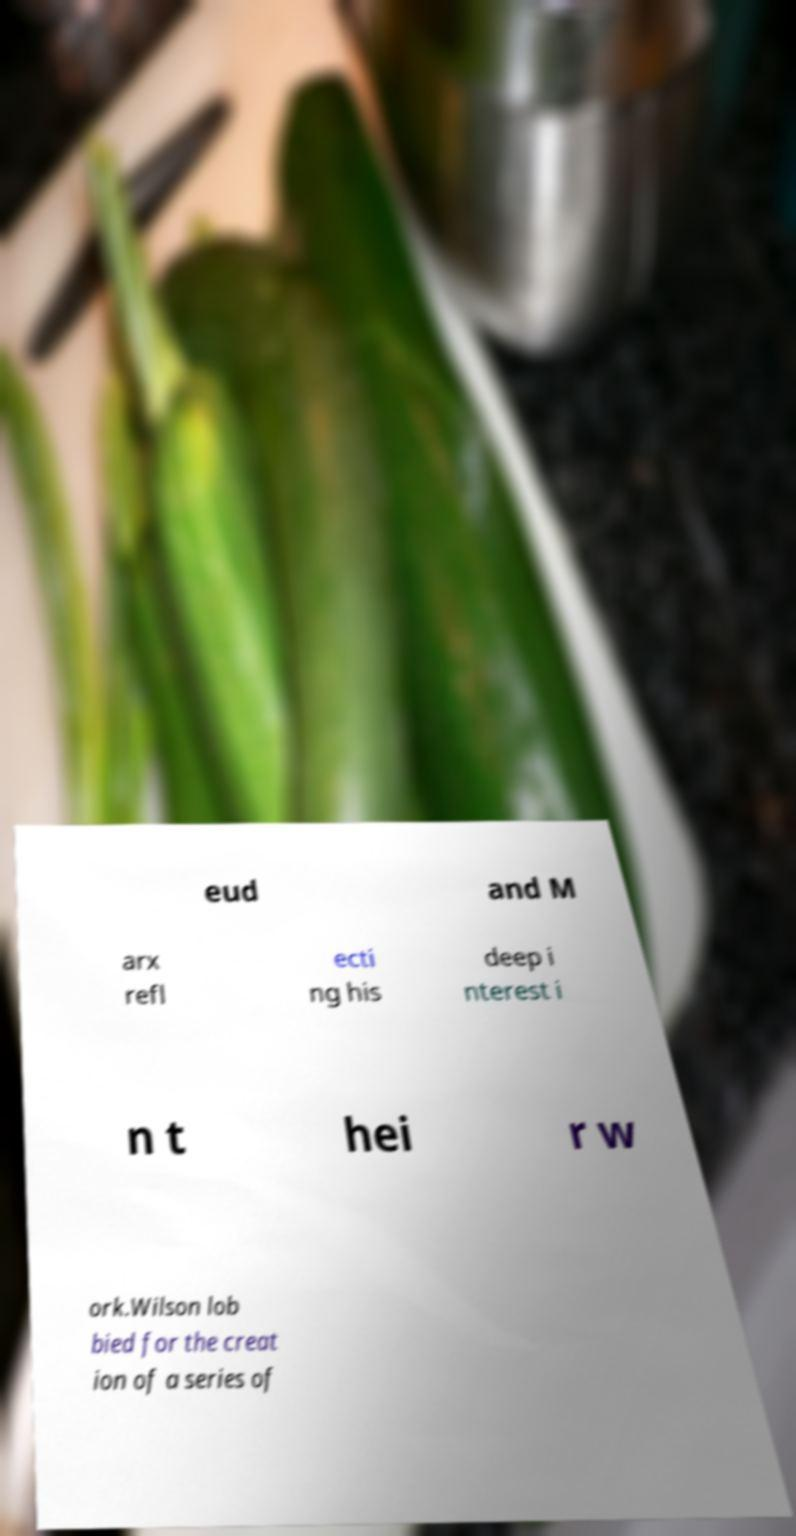What messages or text are displayed in this image? I need them in a readable, typed format. eud and M arx refl ecti ng his deep i nterest i n t hei r w ork.Wilson lob bied for the creat ion of a series of 